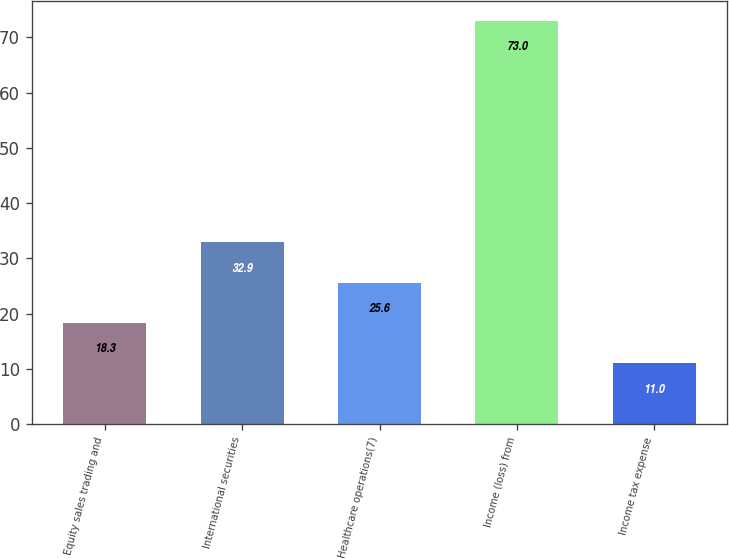Convert chart. <chart><loc_0><loc_0><loc_500><loc_500><bar_chart><fcel>Equity sales trading and<fcel>International securities<fcel>Healthcare operations(7)<fcel>Income (loss) from<fcel>Income tax expense<nl><fcel>18.3<fcel>32.9<fcel>25.6<fcel>73<fcel>11<nl></chart> 